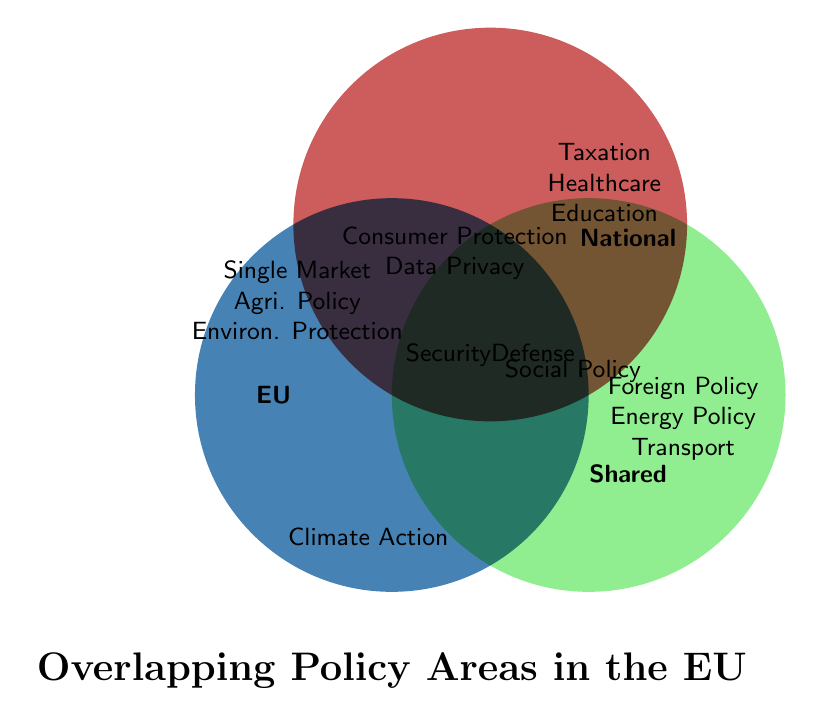What are the policy areas unique to the EU? These are the policy areas only present within the EU circle without overlapping with the other circles. They are Single Market, Common Agricultural Policy, and Environmental Protection.
Answer: Single Market, Common Agricultural Policy, Environmental Protection Which policy areas are shared between the EU and national levels? The policy areas in the overlapping region between the EU and national circles are Consumer Protection and Data Privacy.
Answer: Consumer Protection, Data Privacy Where is Foreign Policy located? Foreign Policy is found in the "Shared" circle within the diagram, indicating it is a policy area that involves both the EU and national levels.
Answer: Shared What policy is located in the intersection of EU, National, and Shared areas? The area where all three circles overlap shows the policy of Security and Defense.
Answer: Security and Defense Are there any policies only shared between National and Shared levels? If so, what are they? Yes, these policies are in the intersection between National and Shared. The policy listed here is Social Policy.
Answer: Social Policy Which entity administers Education Policy? Education Policy is within the National circle indicating it is administered at the national level.
Answer: National What color represents EU policies? The EU policies are represented by the blue circle.
Answer: Blue How many policy areas overlap between EU and Shared but not with National? The intersection between EU and Shared circles, excluding National, includes Climate Action. Hence, there is only one policy in this intersection.
Answer: 1 Which policies are found in the intersection of all three circles? The intersection of all three circles shows Security and Defense as the overlapping policy area among EU, National, and Shared.
Answer: Security and Defense What are the green-colored policies? Green color represents the "Shared" policies which include Foreign Policy, Energy Policy, and Transport.
Answer: Foreign Policy, Energy Policy, Transport 